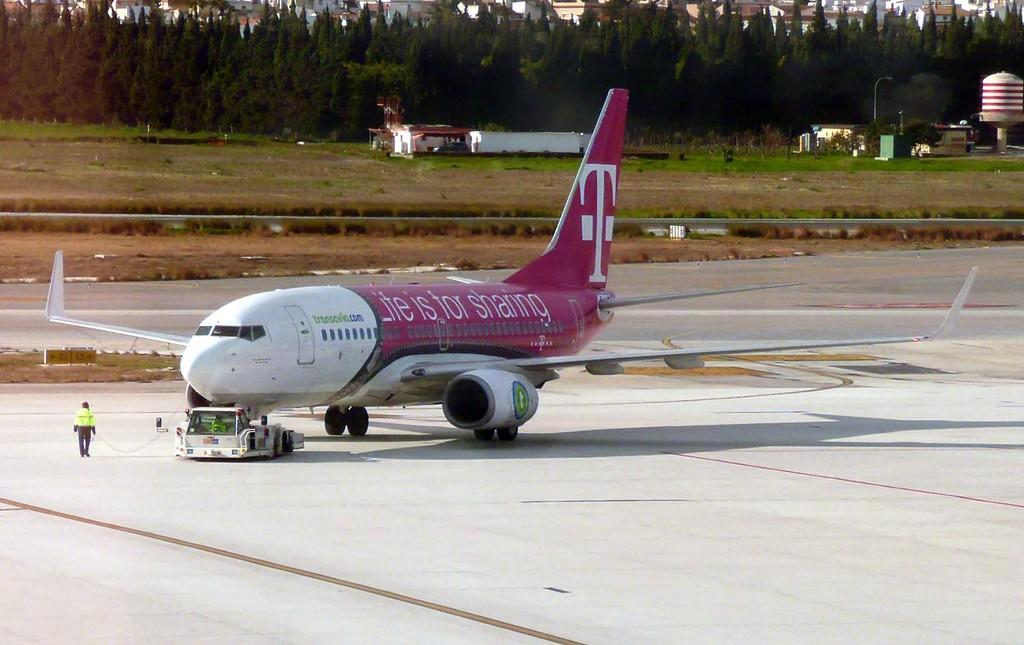<image>
Render a clear and concise summary of the photo. a plane that has the letter T on the back 